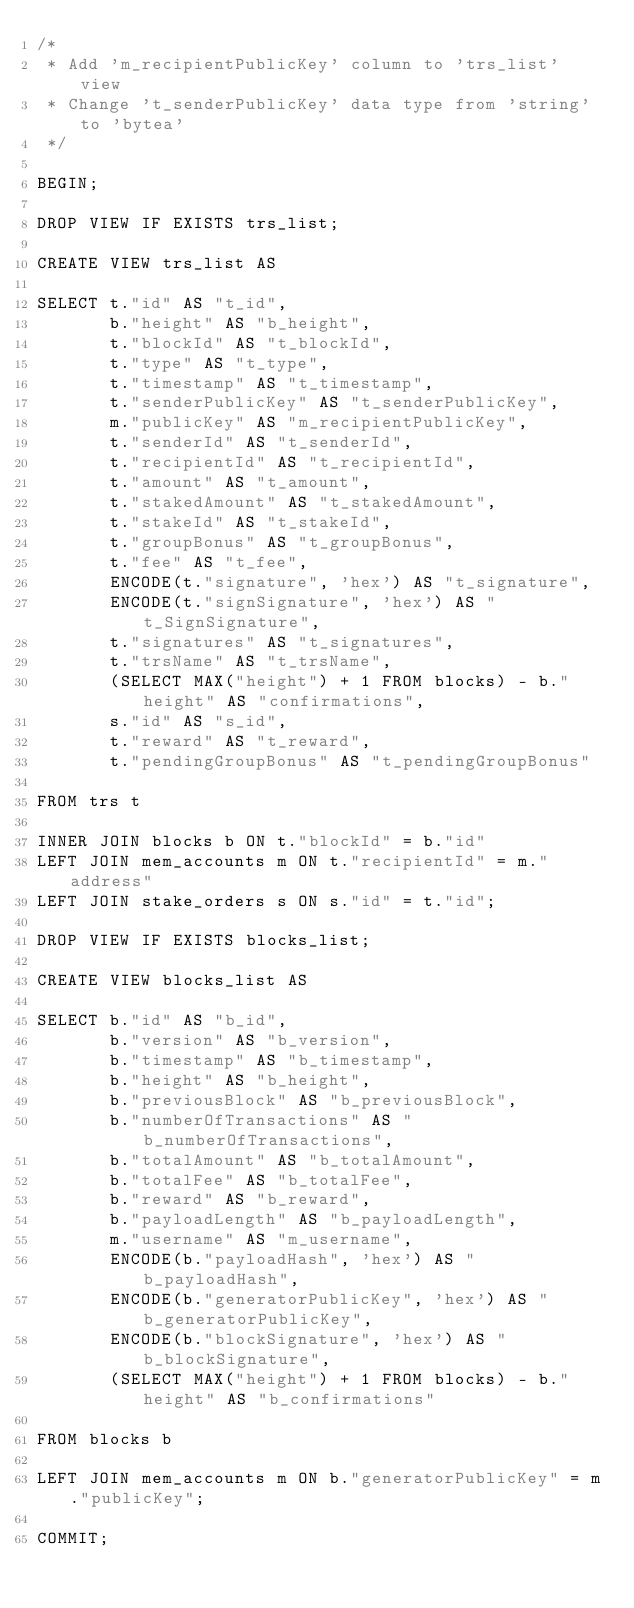<code> <loc_0><loc_0><loc_500><loc_500><_SQL_>/*
 * Add 'm_recipientPublicKey' column to 'trs_list' view
 * Change 't_senderPublicKey' data type from 'string' to 'bytea'
 */

BEGIN;

DROP VIEW IF EXISTS trs_list;

CREATE VIEW trs_list AS

SELECT t."id" AS "t_id",
       b."height" AS "b_height",
       t."blockId" AS "t_blockId",
       t."type" AS "t_type",
       t."timestamp" AS "t_timestamp",
       t."senderPublicKey" AS "t_senderPublicKey",
       m."publicKey" AS "m_recipientPublicKey",
       t."senderId" AS "t_senderId",
       t."recipientId" AS "t_recipientId",
       t."amount" AS "t_amount",
       t."stakedAmount" AS "t_stakedAmount",
       t."stakeId" AS "t_stakeId",
       t."groupBonus" AS "t_groupBonus",
       t."fee" AS "t_fee",
       ENCODE(t."signature", 'hex') AS "t_signature",
       ENCODE(t."signSignature", 'hex') AS "t_SignSignature",
       t."signatures" AS "t_signatures",
       t."trsName" AS "t_trsName",
       (SELECT MAX("height") + 1 FROM blocks) - b."height" AS "confirmations",
       s."id" AS "s_id",
       t."reward" AS "t_reward",
       t."pendingGroupBonus" AS "t_pendingGroupBonus"

FROM trs t

INNER JOIN blocks b ON t."blockId" = b."id"
LEFT JOIN mem_accounts m ON t."recipientId" = m."address"
LEFT JOIN stake_orders s ON s."id" = t."id";

DROP VIEW IF EXISTS blocks_list;

CREATE VIEW blocks_list AS

SELECT b."id" AS "b_id",
       b."version" AS "b_version",
       b."timestamp" AS "b_timestamp",
       b."height" AS "b_height",
       b."previousBlock" AS "b_previousBlock",
       b."numberOfTransactions" AS "b_numberOfTransactions",
       b."totalAmount" AS "b_totalAmount",
       b."totalFee" AS "b_totalFee",
       b."reward" AS "b_reward",
       b."payloadLength" AS "b_payloadLength",
       m."username" AS "m_username",
       ENCODE(b."payloadHash", 'hex') AS "b_payloadHash",
       ENCODE(b."generatorPublicKey", 'hex') AS "b_generatorPublicKey",
       ENCODE(b."blockSignature", 'hex') AS "b_blockSignature",
       (SELECT MAX("height") + 1 FROM blocks) - b."height" AS "b_confirmations"

FROM blocks b

LEFT JOIN mem_accounts m ON b."generatorPublicKey" = m."publicKey";

COMMIT;
</code> 